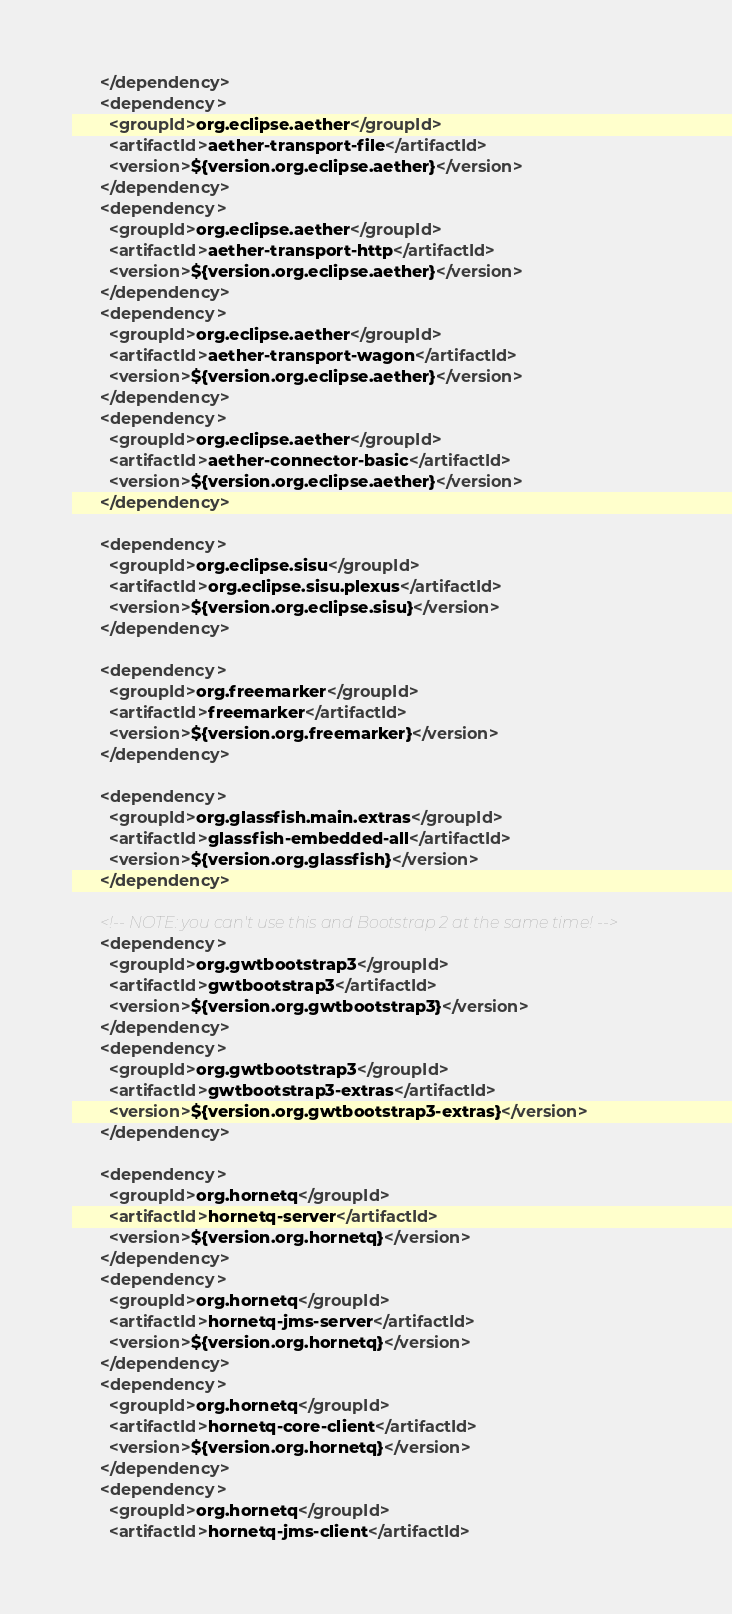<code> <loc_0><loc_0><loc_500><loc_500><_XML_>      </dependency>
      <dependency>
        <groupId>org.eclipse.aether</groupId>
        <artifactId>aether-transport-file</artifactId>
        <version>${version.org.eclipse.aether}</version>
      </dependency>
      <dependency>
        <groupId>org.eclipse.aether</groupId>
        <artifactId>aether-transport-http</artifactId>
        <version>${version.org.eclipse.aether}</version>
      </dependency>
      <dependency>
        <groupId>org.eclipse.aether</groupId>
        <artifactId>aether-transport-wagon</artifactId>
        <version>${version.org.eclipse.aether}</version>
      </dependency>
      <dependency>
        <groupId>org.eclipse.aether</groupId>
        <artifactId>aether-connector-basic</artifactId>
        <version>${version.org.eclipse.aether}</version>
      </dependency>

      <dependency>
        <groupId>org.eclipse.sisu</groupId>
        <artifactId>org.eclipse.sisu.plexus</artifactId>
        <version>${version.org.eclipse.sisu}</version>
      </dependency>

      <dependency>
        <groupId>org.freemarker</groupId>
        <artifactId>freemarker</artifactId>
        <version>${version.org.freemarker}</version>
      </dependency>

      <dependency>
        <groupId>org.glassfish.main.extras</groupId>
        <artifactId>glassfish-embedded-all</artifactId>
        <version>${version.org.glassfish}</version>
      </dependency>

      <!-- NOTE: you can't use this and Bootstrap 2 at the same time! -->
      <dependency>
        <groupId>org.gwtbootstrap3</groupId>
        <artifactId>gwtbootstrap3</artifactId>
        <version>${version.org.gwtbootstrap3}</version>
      </dependency>
      <dependency>
        <groupId>org.gwtbootstrap3</groupId>
        <artifactId>gwtbootstrap3-extras</artifactId>
        <version>${version.org.gwtbootstrap3-extras}</version>
      </dependency>

      <dependency>
        <groupId>org.hornetq</groupId>
        <artifactId>hornetq-server</artifactId>
        <version>${version.org.hornetq}</version>
      </dependency>
      <dependency>
        <groupId>org.hornetq</groupId>
        <artifactId>hornetq-jms-server</artifactId>
        <version>${version.org.hornetq}</version>
      </dependency>
      <dependency>
        <groupId>org.hornetq</groupId>
        <artifactId>hornetq-core-client</artifactId>
        <version>${version.org.hornetq}</version>
      </dependency>
      <dependency>
        <groupId>org.hornetq</groupId>
        <artifactId>hornetq-jms-client</artifactId></code> 